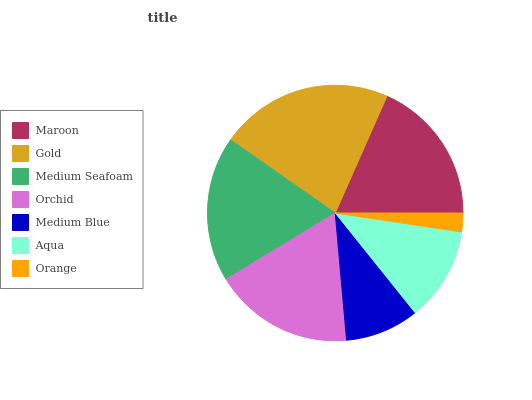Is Orange the minimum?
Answer yes or no. Yes. Is Gold the maximum?
Answer yes or no. Yes. Is Medium Seafoam the minimum?
Answer yes or no. No. Is Medium Seafoam the maximum?
Answer yes or no. No. Is Gold greater than Medium Seafoam?
Answer yes or no. Yes. Is Medium Seafoam less than Gold?
Answer yes or no. Yes. Is Medium Seafoam greater than Gold?
Answer yes or no. No. Is Gold less than Medium Seafoam?
Answer yes or no. No. Is Orchid the high median?
Answer yes or no. Yes. Is Orchid the low median?
Answer yes or no. Yes. Is Maroon the high median?
Answer yes or no. No. Is Maroon the low median?
Answer yes or no. No. 